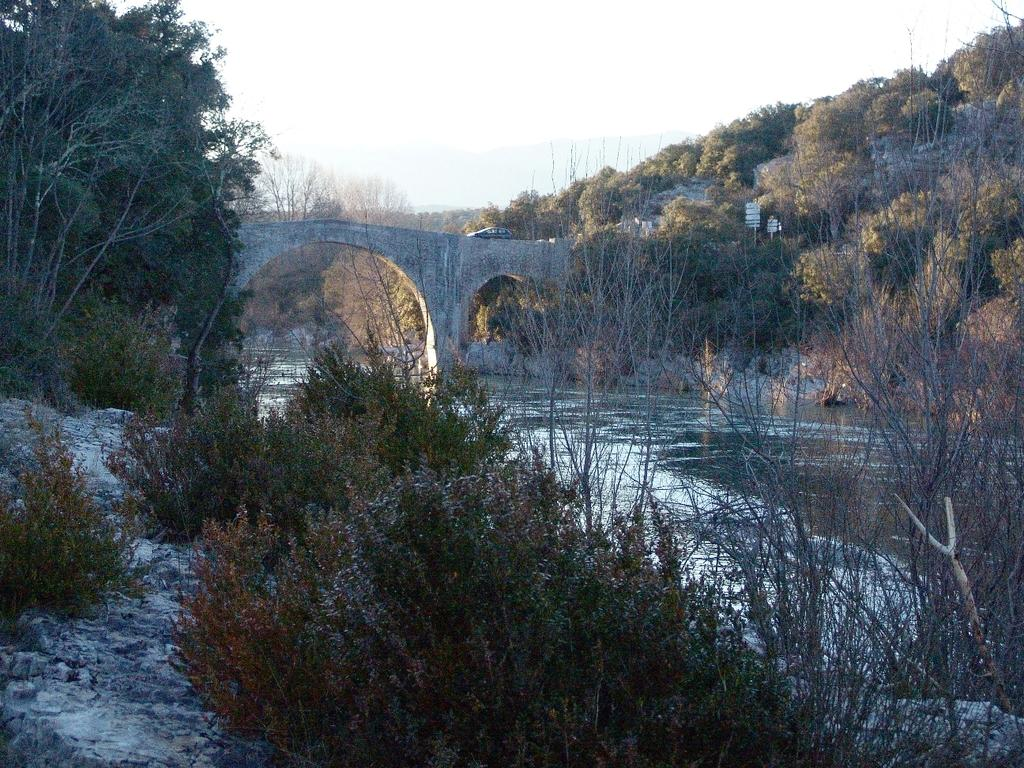What type of natural elements can be seen in the image? There are trees and a river in the image. What is the vehicle doing in the image? A vehicle is moving on a bridge in the image. What are the boards used for in the image? The purpose of the boards is not clear from the image. What can be seen in the background of the image? The sky is visible in the background of the image. What type of noise can be heard coming from the trees in the image? There is no indication of sound in the image, so it's not possible to determine what noise might be heard from the trees. 